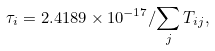Convert formula to latex. <formula><loc_0><loc_0><loc_500><loc_500>\tau _ { i } = 2 . 4 1 8 9 \times 1 0 ^ { - 1 7 } / { \sum _ { j } T _ { i j } } ,</formula> 